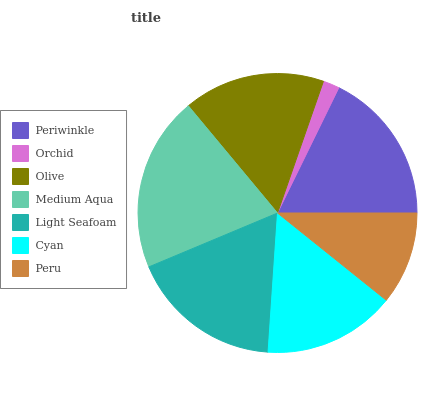Is Orchid the minimum?
Answer yes or no. Yes. Is Medium Aqua the maximum?
Answer yes or no. Yes. Is Olive the minimum?
Answer yes or no. No. Is Olive the maximum?
Answer yes or no. No. Is Olive greater than Orchid?
Answer yes or no. Yes. Is Orchid less than Olive?
Answer yes or no. Yes. Is Orchid greater than Olive?
Answer yes or no. No. Is Olive less than Orchid?
Answer yes or no. No. Is Olive the high median?
Answer yes or no. Yes. Is Olive the low median?
Answer yes or no. Yes. Is Orchid the high median?
Answer yes or no. No. Is Cyan the low median?
Answer yes or no. No. 